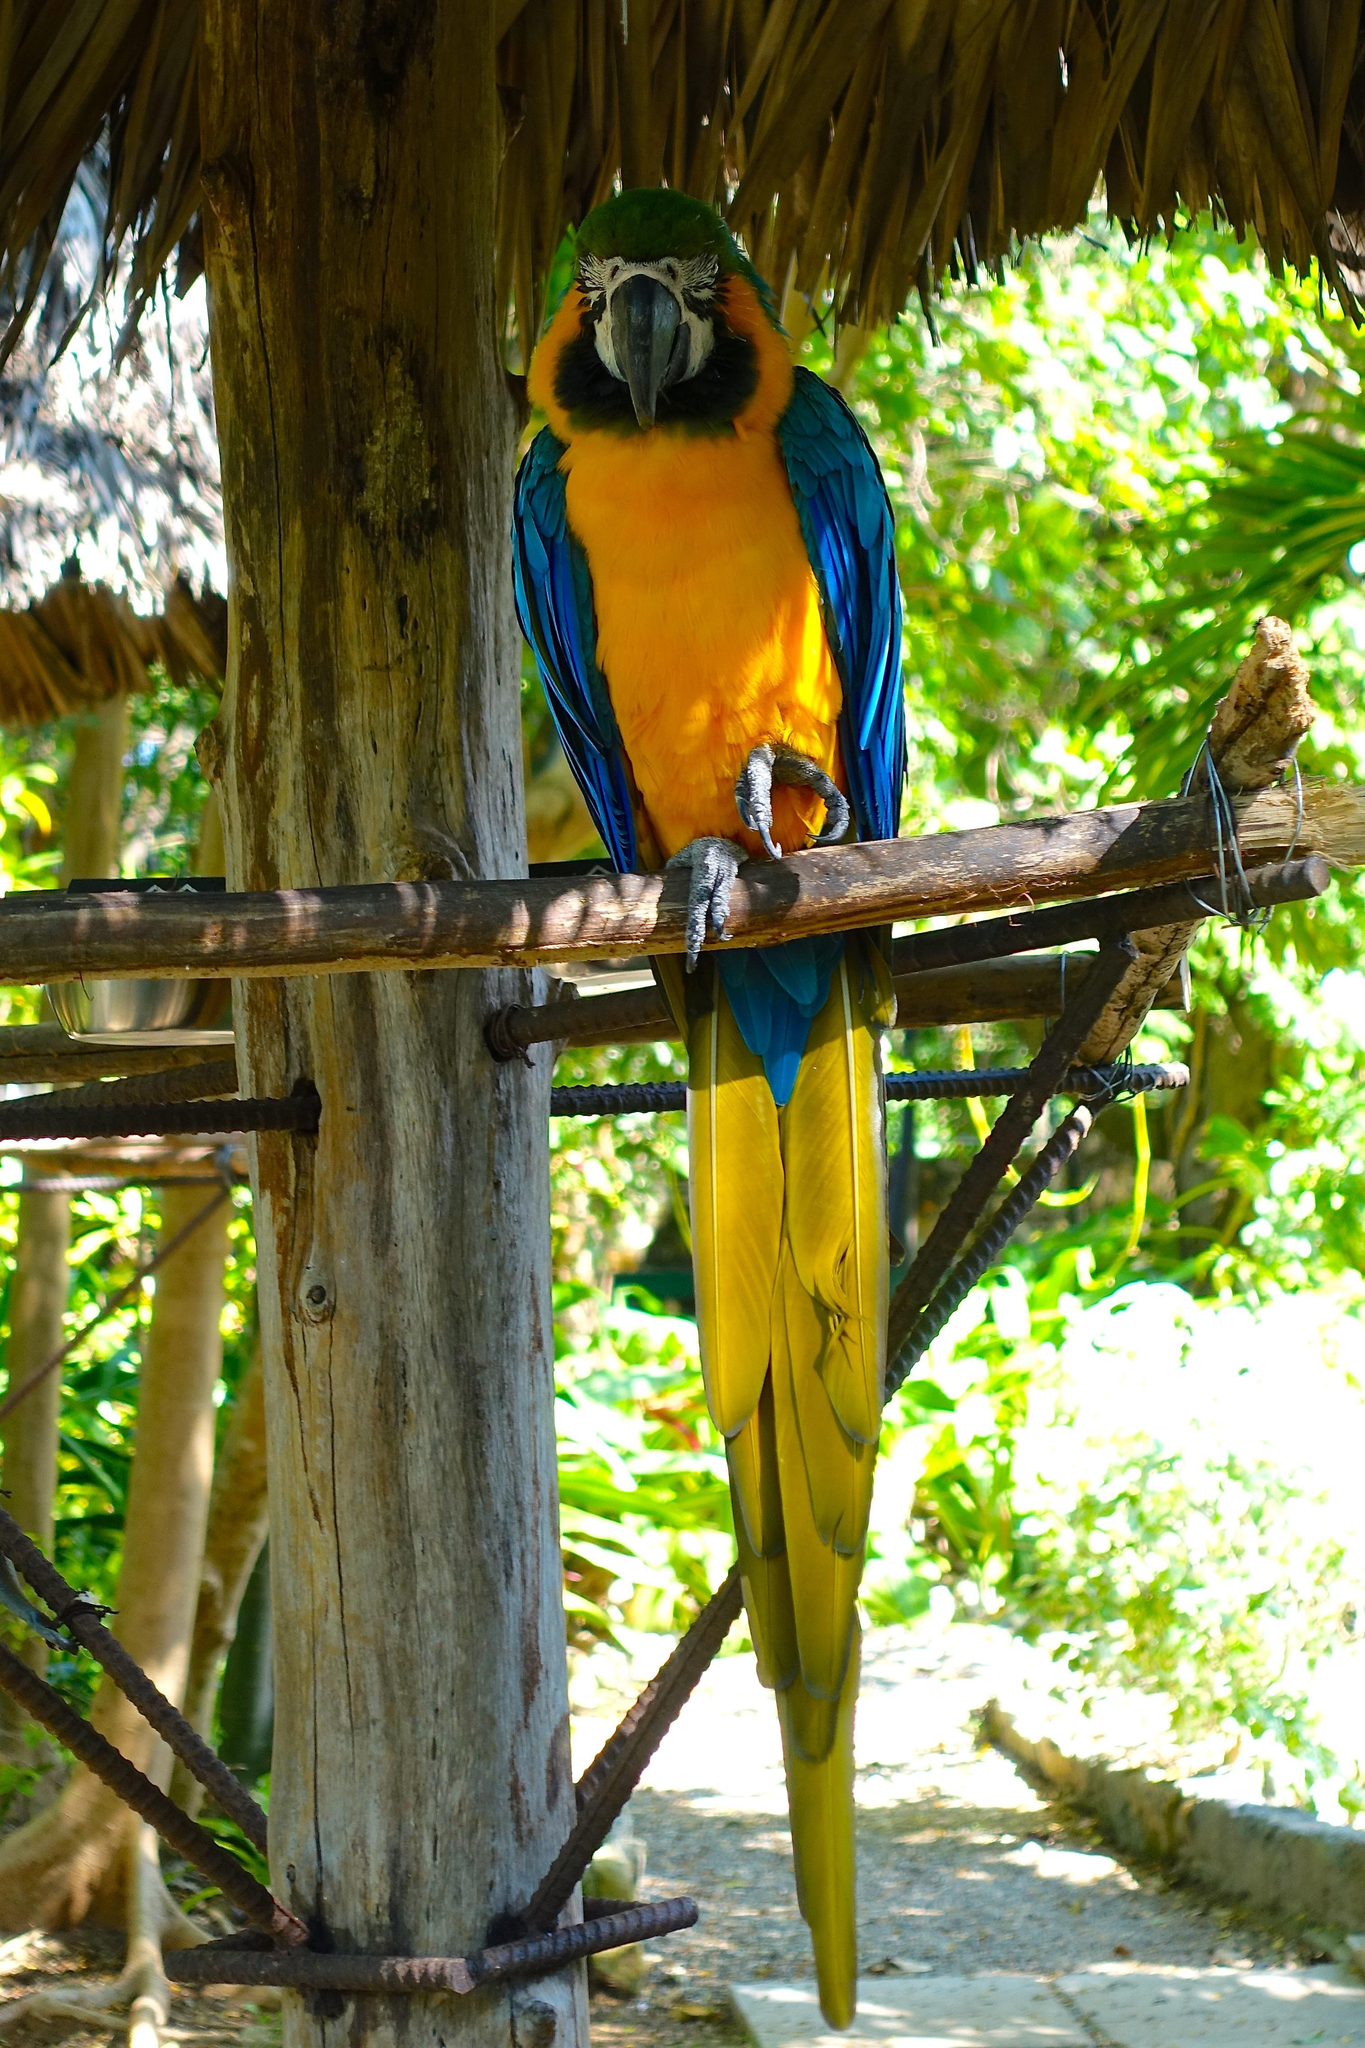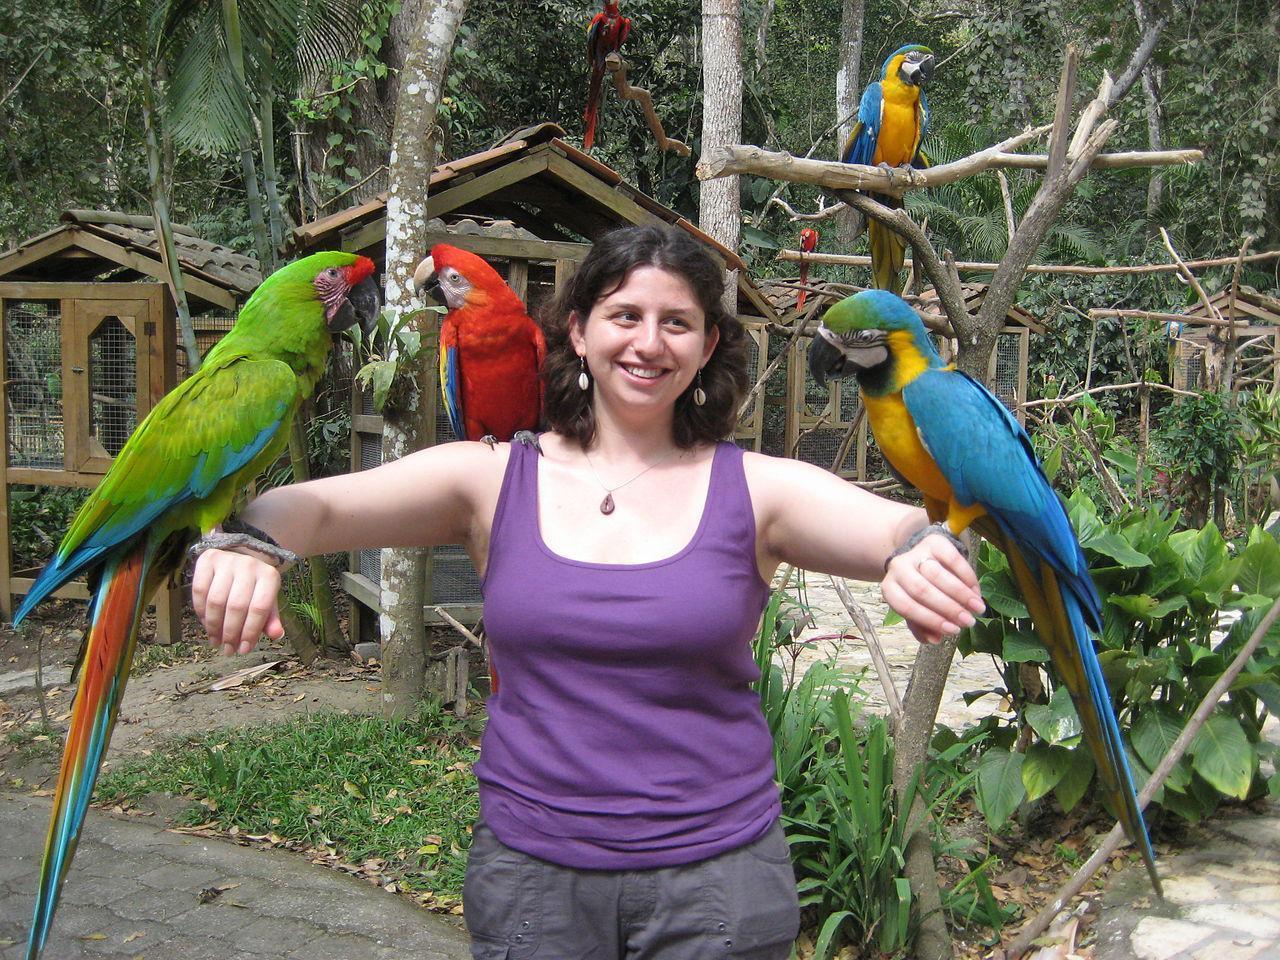The first image is the image on the left, the second image is the image on the right. For the images displayed, is the sentence "At least one image shows a person with three parrots perched somewhere on their body." factually correct? Answer yes or no. Yes. The first image is the image on the left, the second image is the image on the right. Considering the images on both sides, is "In one image, a person is standing in front of a roofed and screened cage area with three different colored parrots perched them." valid? Answer yes or no. Yes. 